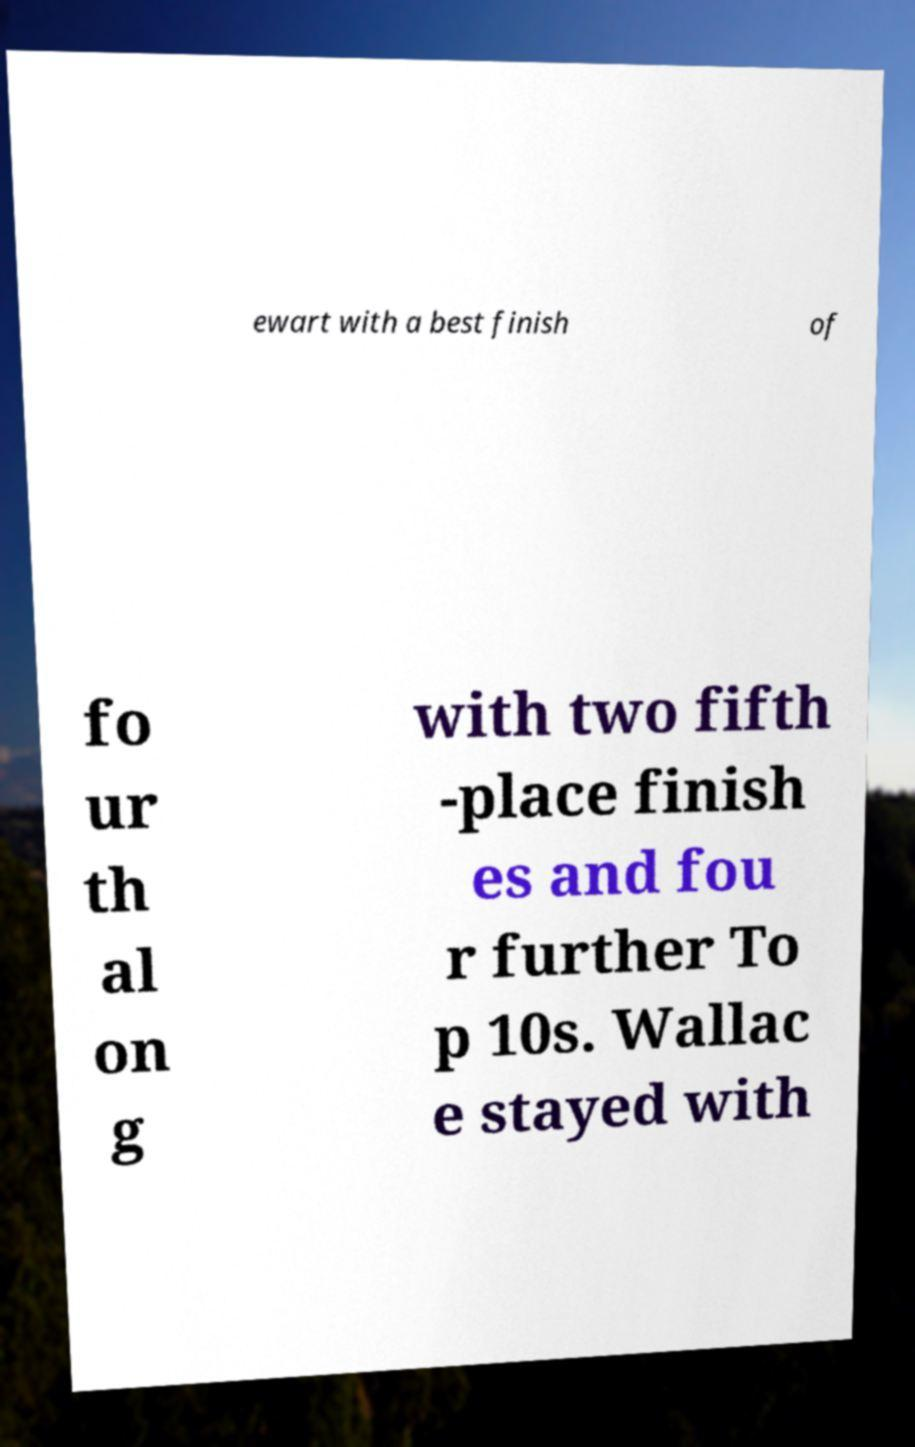There's text embedded in this image that I need extracted. Can you transcribe it verbatim? ewart with a best finish of fo ur th al on g with two fifth -place finish es and fou r further To p 10s. Wallac e stayed with 